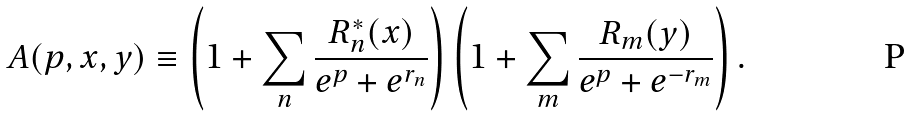Convert formula to latex. <formula><loc_0><loc_0><loc_500><loc_500>A ( p , x , y ) \equiv \left ( 1 + \sum _ { n } \frac { R _ { n } ^ { * } ( x ) } { e ^ { p } + e ^ { r _ { n } } } \right ) \left ( 1 + \sum _ { m } \frac { R _ { m } ( y ) } { e ^ { p } + e ^ { - r _ { m } } } \right ) .</formula> 